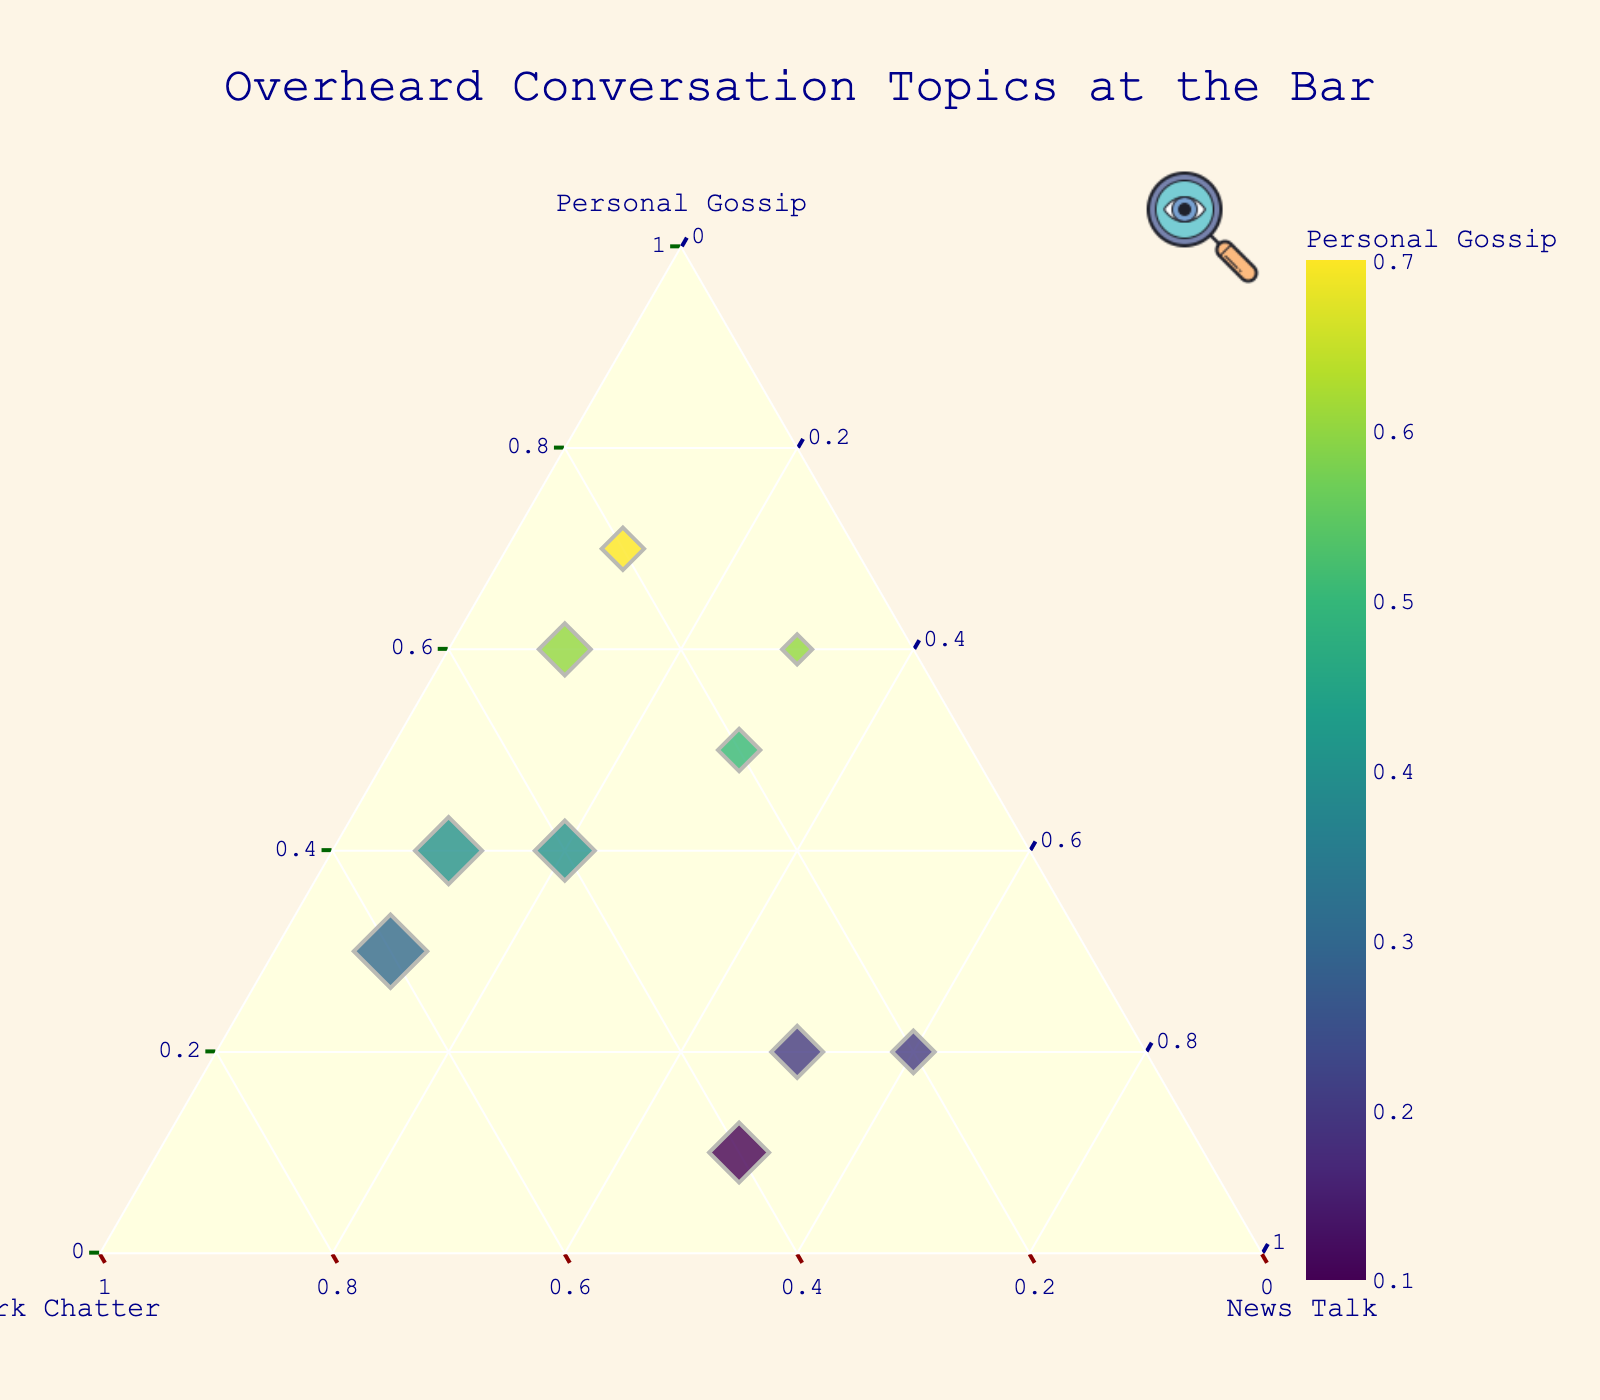How many data points are there on the plot? By counting the number of individual marker points present on the ternary plot, you can determine the total number of data points.
Answer: 10 What are the proportions of topics for the most personal conversation? The data point with the highest value on the "Personal Gossip" axis represents the most personal conversation. Look for the point farthest towards the "Personal Gossip" axis.
Answer: 0.7, 0.2, 0.1 Which topic is least discussed overall? By comparing the axis values across all points, sum the contributions to each axis and see which is lowest: Personal, Work-related, or Current events.
Answer: Current events Is there any point where the proportions are equal? Examine the data points to see if there exists one where the values for Personal, Work-related, and Current events are all the same.
Answer: No What is the median proportion of work-related topics? Sort the "Work-related" values and choose the middle value. If there are an even number of points, the median is the average of the two middle values.
Answer: 0.3 Compare the number of points where personal gossip is more discussed than work-related topics. How many such points are here? Identify the data points where the "Personal Gossip" value is greater than the "Work-related" value and count them.
Answer: 6 What are the proportions of the data point closest to the icon? Since the icon is placed at (1.02, 1.05) on the paper coordinates, find the point closest to this icon visually on the plot. It represents the point with values making it closest to top-right in the ternary plot in all proportion values.
Answer: 0.6, 0.3, 0.1 Which data point has the largest contribution from current events? Find the point which has the highest value under the "Current Events" category. The position of this point is the closest to the "Current Events" vertex.
Answer: 0.2, 0.2, 0.6 How many different marker sizes can you find? By observing the marker sizes, which vary based on the "Work-related" value, count the distinct marker sizes visible.
Answer: 4 What's the average proportion of current events in conversations? Sum all values of current events and divide by the number of data points (sum: 0.1+0.1+0.5+0.1+0.1+0.3+0.5+0.2+0.6+0.3).
Answer: 0.28 